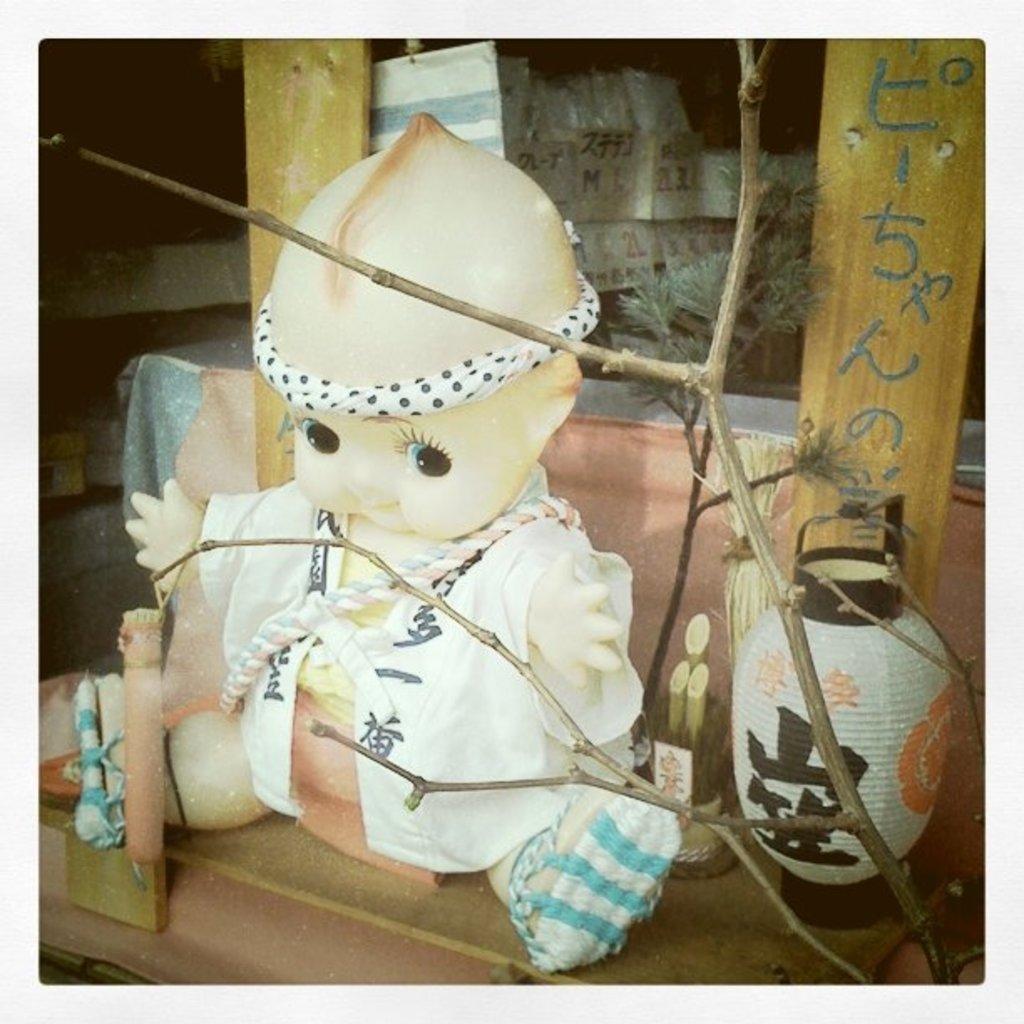Could you give a brief overview of what you see in this image? In the image there is a doll and there is a lantern beside the doll, in front of the lantern there are branches of a dry tree and in the background there are some goods. 